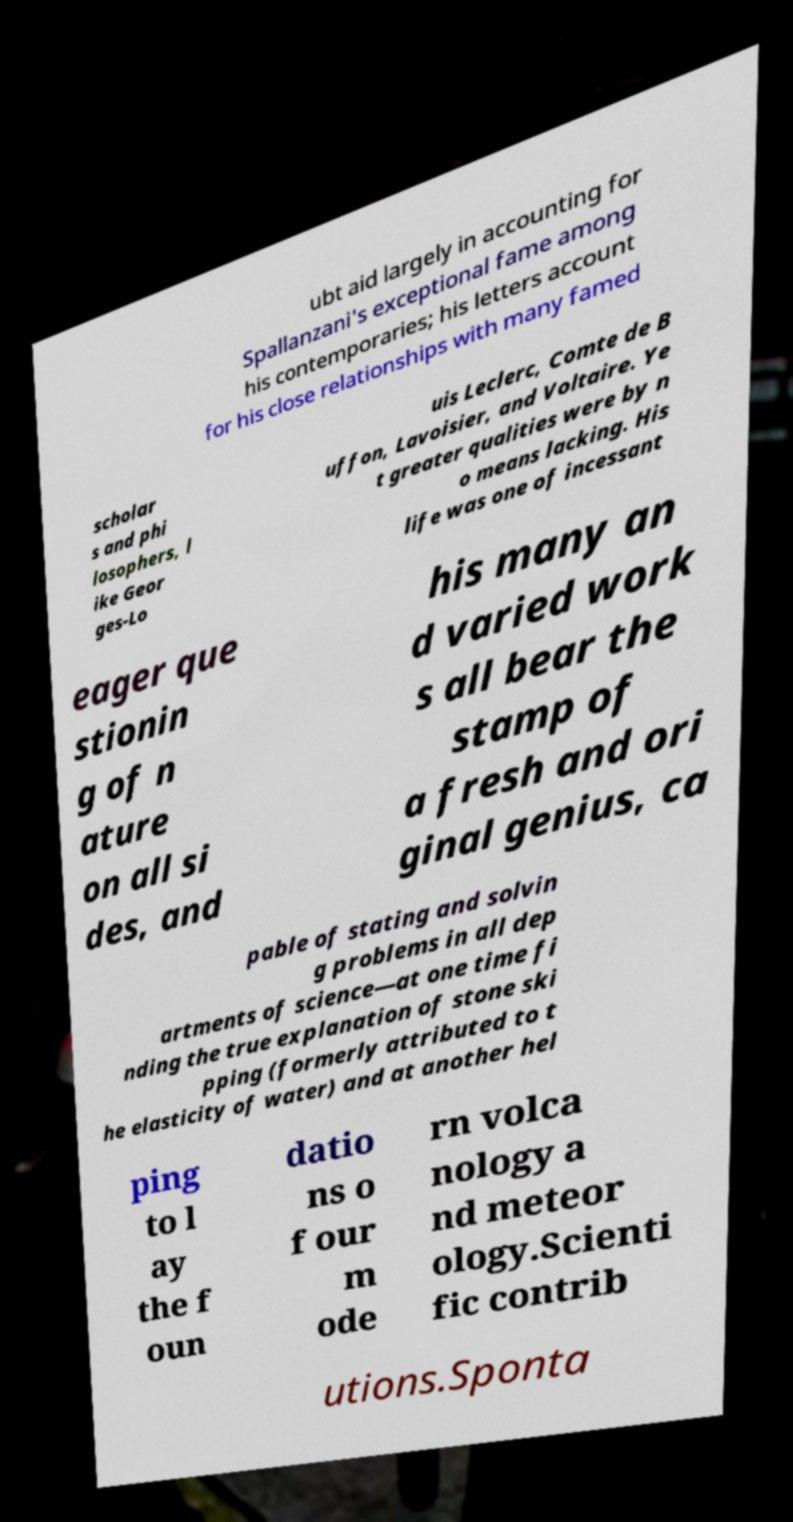Please read and relay the text visible in this image. What does it say? ubt aid largely in accounting for Spallanzani's exceptional fame among his contemporaries; his letters account for his close relationships with many famed scholar s and phi losophers, l ike Geor ges-Lo uis Leclerc, Comte de B uffon, Lavoisier, and Voltaire. Ye t greater qualities were by n o means lacking. His life was one of incessant eager que stionin g of n ature on all si des, and his many an d varied work s all bear the stamp of a fresh and ori ginal genius, ca pable of stating and solvin g problems in all dep artments of science—at one time fi nding the true explanation of stone ski pping (formerly attributed to t he elasticity of water) and at another hel ping to l ay the f oun datio ns o f our m ode rn volca nology a nd meteor ology.Scienti fic contrib utions.Sponta 